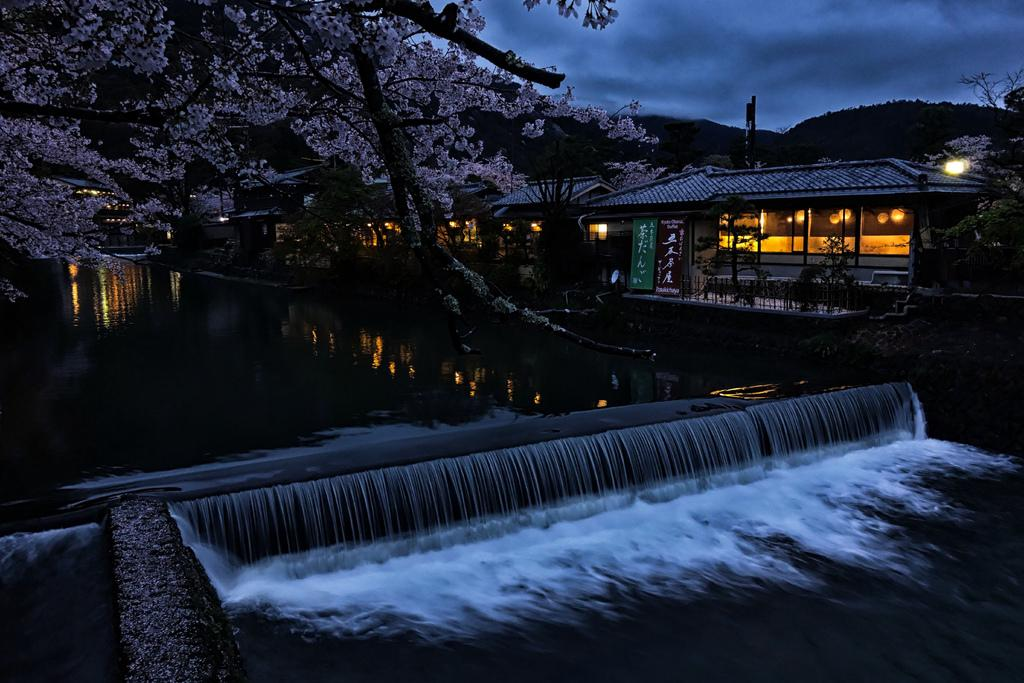What natural feature is the main subject of the image? There is a waterfall in the image. What body of water is located near the waterfall? There is a pond in the image. What type of vegetation is visible behind the waterfall? There are trees behind the waterfall. What structures can be seen on the right side of the image? There are homes with lights on the right side of the image. What is visible in the sky in the image? The sky is visible in the image, and clouds are present. What type of agreement is being signed by the bucket in the image? There is no bucket present in the image, and therefore no agreement can be signed. 